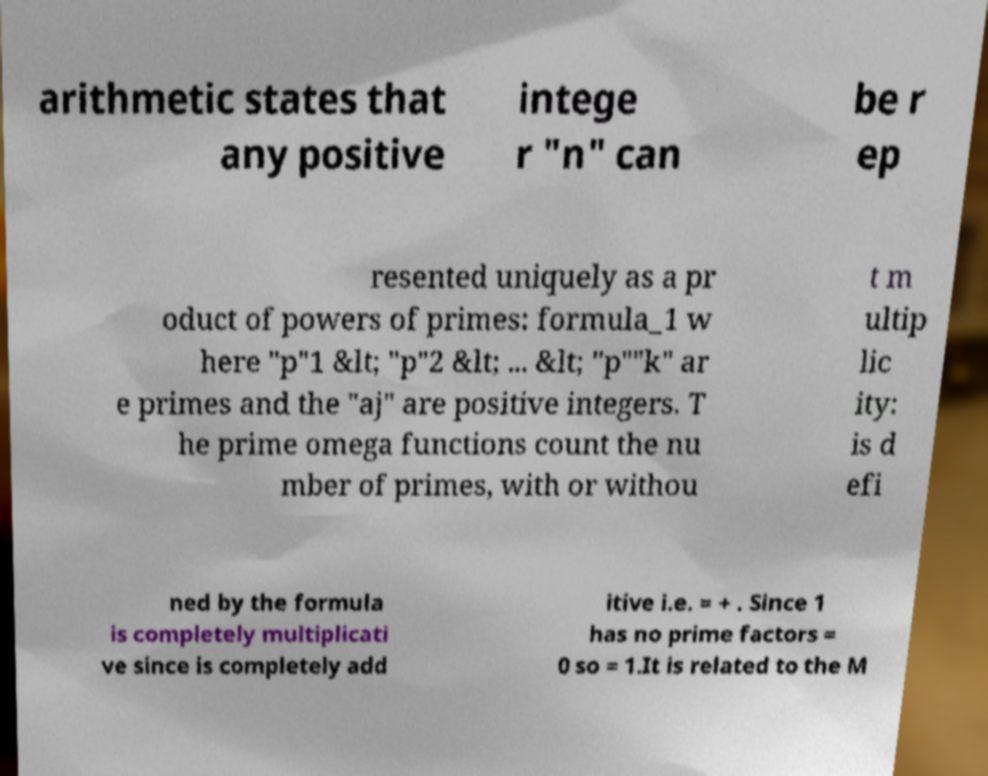Please read and relay the text visible in this image. What does it say? arithmetic states that any positive intege r "n" can be r ep resented uniquely as a pr oduct of powers of primes: formula_1 w here "p"1 &lt; "p"2 &lt; ... &lt; "p""k" ar e primes and the "aj" are positive integers. T he prime omega functions count the nu mber of primes, with or withou t m ultip lic ity: is d efi ned by the formula is completely multiplicati ve since is completely add itive i.e. = + . Since 1 has no prime factors = 0 so = 1.It is related to the M 